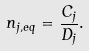Convert formula to latex. <formula><loc_0><loc_0><loc_500><loc_500>n _ { j , e q } = \frac { C _ { j } } { D _ { j } } .</formula> 